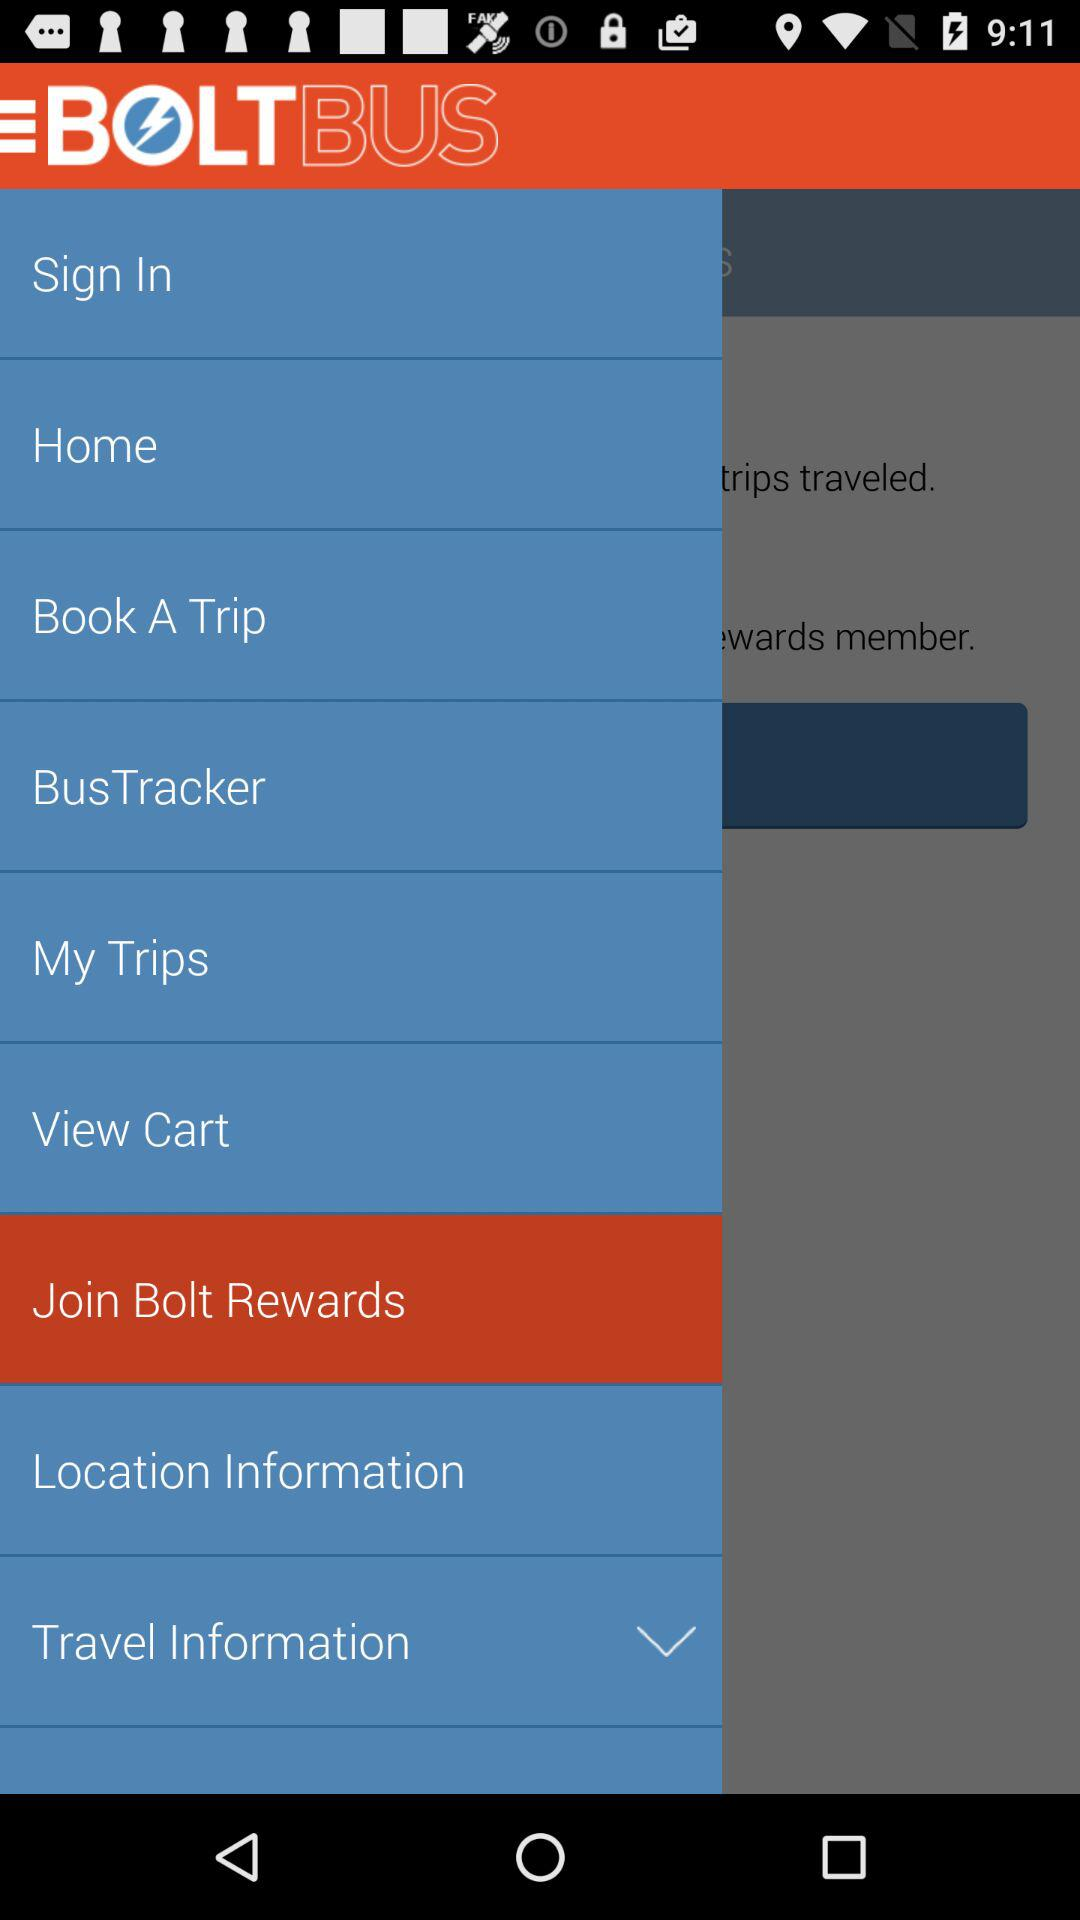What is the selected item? The selected item is "Join Bolt Rewards". 